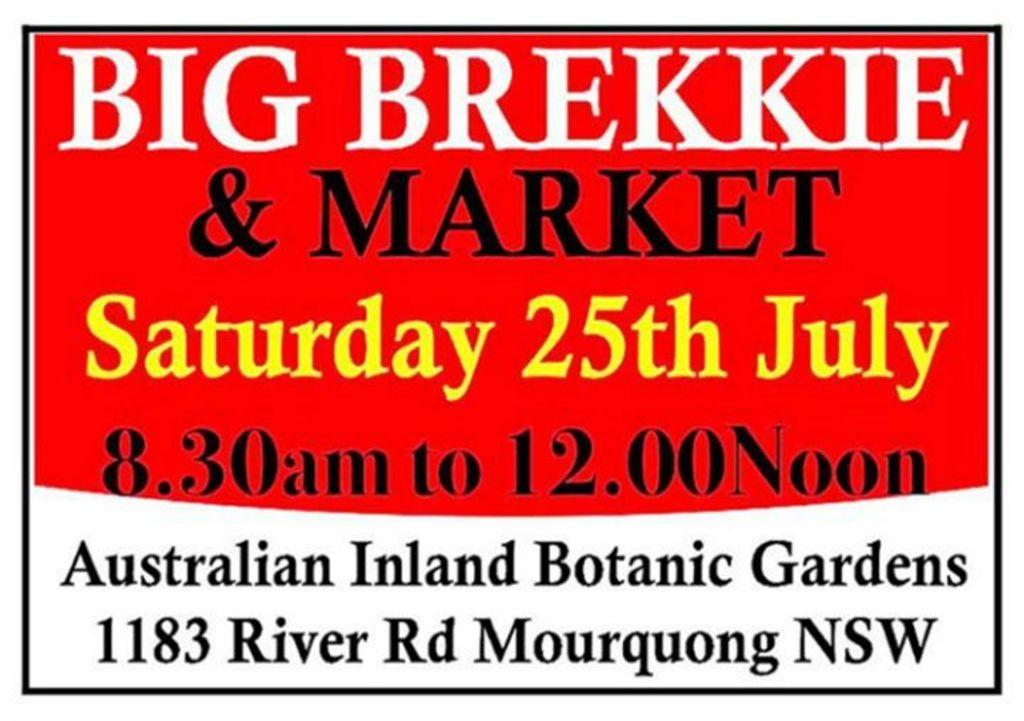Provide a one-sentence caption for the provided image. A sign advertises an event for Saturday, the 25th of July. 